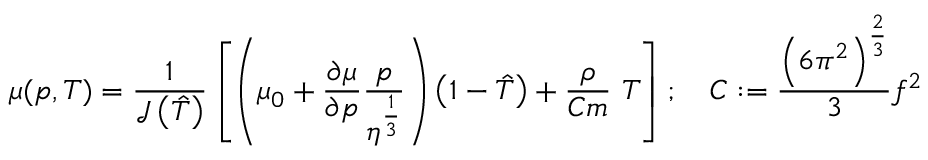Convert formula to latex. <formula><loc_0><loc_0><loc_500><loc_500>\mu ( p , T ) = { \frac { 1 } { { \mathcal { J } } \left ( { \hat { T } } \right ) } } \left [ \left ( \mu _ { 0 } + { \frac { \partial \mu } { \partial p } } { \frac { p } { \eta ^ { \frac { 1 } { 3 } } } } \right ) \left ( 1 - { \hat { T } } \right ) + { \frac { \rho } { C m } } T \right ] ; \quad C \colon = { \frac { \left ( 6 \pi ^ { 2 } \right ) ^ { \frac { 2 } { 3 } } } { 3 } } f ^ { 2 }</formula> 